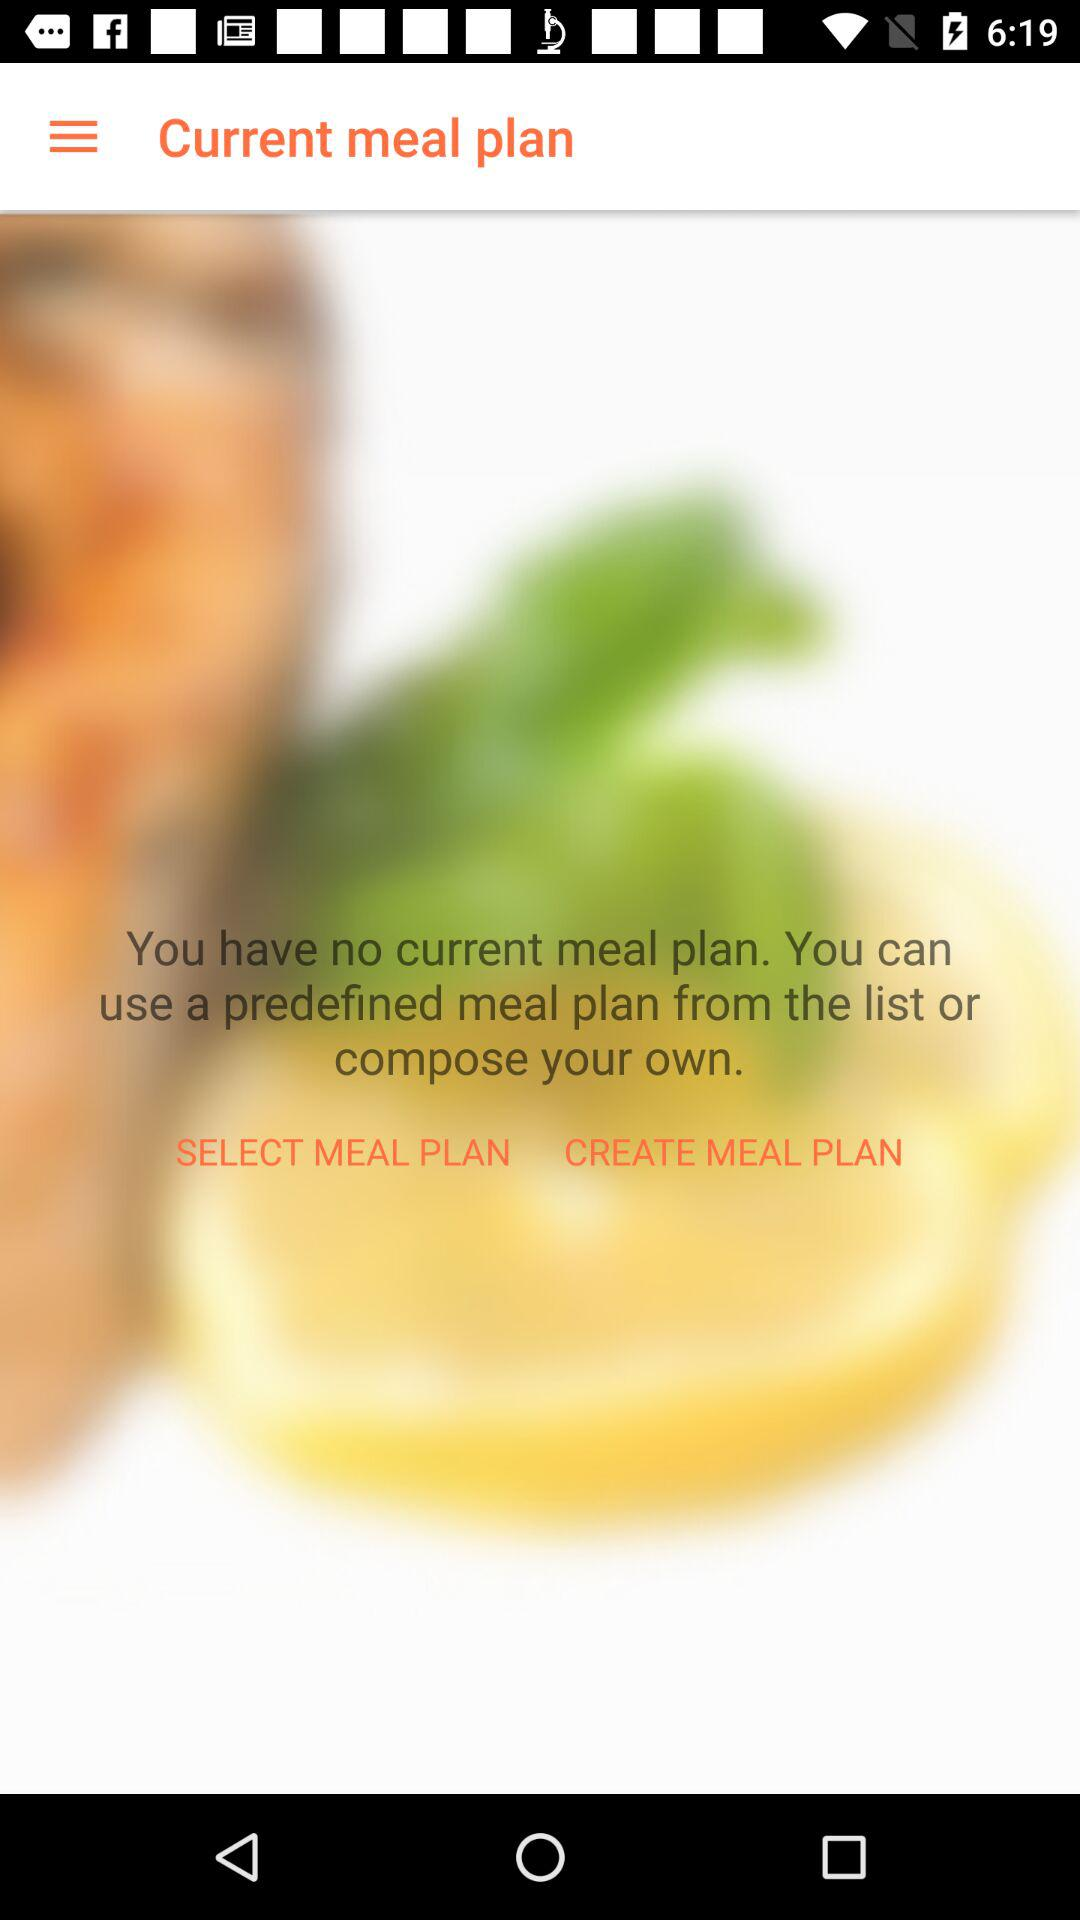What is the application name?
When the provided information is insufficient, respond with <no answer>. <no answer> 